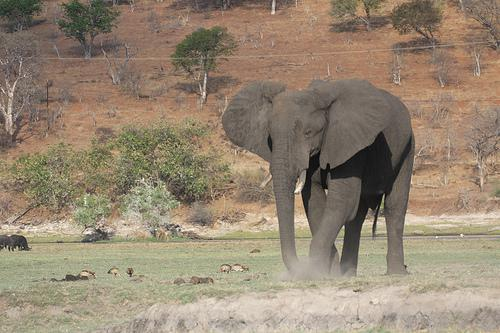Question: what is the large animal?
Choices:
A. Whale.
B. Elephant.
C. Dog.
D. Dinosaur.
Answer with the letter. Answer: B Question: where are the tusks?
Choices:
A. On the boar.
B. On the walrus.
C. In the museum case.
D. On the elephant.
Answer with the letter. Answer: D Question: what color is the hillside?
Choices:
A. Green.
B. Red.
C. Brown.
D. Orange.
Answer with the letter. Answer: C 